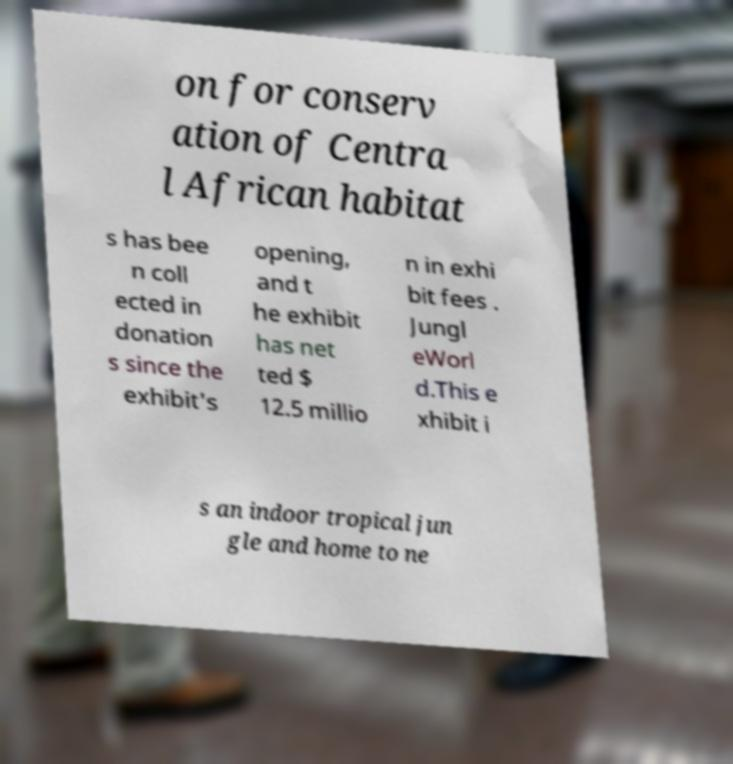Please identify and transcribe the text found in this image. on for conserv ation of Centra l African habitat s has bee n coll ected in donation s since the exhibit's opening, and t he exhibit has net ted $ 12.5 millio n in exhi bit fees . Jungl eWorl d.This e xhibit i s an indoor tropical jun gle and home to ne 